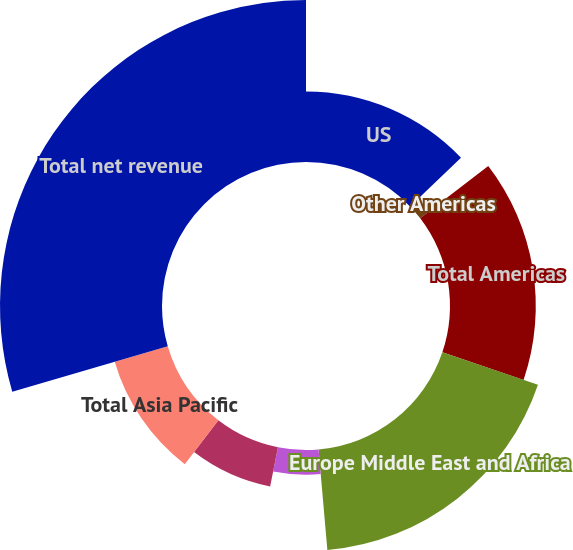<chart> <loc_0><loc_0><loc_500><loc_500><pie_chart><fcel>US<fcel>Other Americas<fcel>Total Americas<fcel>Europe Middle East and Africa<fcel>Japan<fcel>Other Asia Pacific<fcel>Total Asia Pacific<fcel>Total net revenue<nl><fcel>12.85%<fcel>1.73%<fcel>15.63%<fcel>18.4%<fcel>4.51%<fcel>7.29%<fcel>10.07%<fcel>29.52%<nl></chart> 